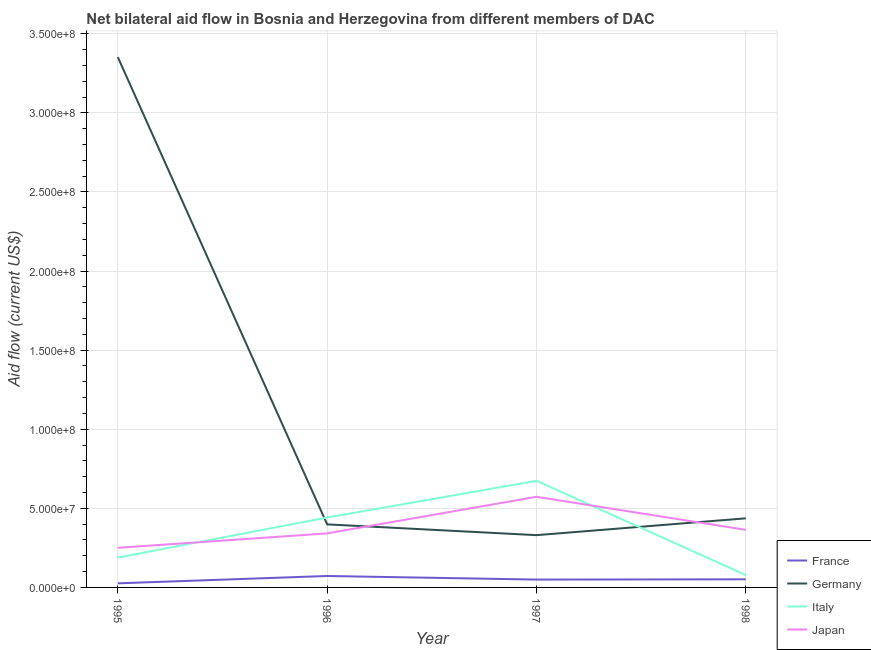What is the amount of aid given by germany in 1998?
Keep it short and to the point. 4.37e+07. Across all years, what is the maximum amount of aid given by germany?
Your answer should be very brief. 3.35e+08. Across all years, what is the minimum amount of aid given by italy?
Offer a terse response. 7.77e+06. In which year was the amount of aid given by italy maximum?
Offer a very short reply. 1997. In which year was the amount of aid given by germany minimum?
Ensure brevity in your answer.  1997. What is the total amount of aid given by france in the graph?
Make the answer very short. 1.99e+07. What is the difference between the amount of aid given by japan in 1996 and that in 1998?
Offer a very short reply. -2.23e+06. What is the difference between the amount of aid given by italy in 1998 and the amount of aid given by france in 1996?
Make the answer very short. 5.40e+05. What is the average amount of aid given by germany per year?
Provide a succinct answer. 1.13e+08. In the year 1995, what is the difference between the amount of aid given by france and amount of aid given by italy?
Give a very brief answer. -1.63e+07. In how many years, is the amount of aid given by italy greater than 180000000 US$?
Offer a very short reply. 0. What is the ratio of the amount of aid given by france in 1996 to that in 1997?
Offer a very short reply. 1.46. Is the amount of aid given by germany in 1996 less than that in 1997?
Your response must be concise. No. What is the difference between the highest and the second highest amount of aid given by japan?
Provide a succinct answer. 2.09e+07. What is the difference between the highest and the lowest amount of aid given by italy?
Your answer should be very brief. 5.96e+07. In how many years, is the amount of aid given by germany greater than the average amount of aid given by germany taken over all years?
Provide a short and direct response. 1. Is it the case that in every year, the sum of the amount of aid given by japan and amount of aid given by france is greater than the sum of amount of aid given by italy and amount of aid given by germany?
Give a very brief answer. No. Does the amount of aid given by italy monotonically increase over the years?
Offer a terse response. No. Is the amount of aid given by france strictly greater than the amount of aid given by germany over the years?
Offer a terse response. No. Is the amount of aid given by japan strictly less than the amount of aid given by france over the years?
Your answer should be very brief. No. Are the values on the major ticks of Y-axis written in scientific E-notation?
Offer a terse response. Yes. What is the title of the graph?
Provide a short and direct response. Net bilateral aid flow in Bosnia and Herzegovina from different members of DAC. Does "Secondary vocational" appear as one of the legend labels in the graph?
Provide a short and direct response. No. What is the Aid flow (current US$) of France in 1995?
Your answer should be compact. 2.59e+06. What is the Aid flow (current US$) in Germany in 1995?
Offer a terse response. 3.35e+08. What is the Aid flow (current US$) of Italy in 1995?
Your response must be concise. 1.89e+07. What is the Aid flow (current US$) of Japan in 1995?
Offer a very short reply. 2.50e+07. What is the Aid flow (current US$) of France in 1996?
Make the answer very short. 7.23e+06. What is the Aid flow (current US$) in Germany in 1996?
Your answer should be very brief. 3.99e+07. What is the Aid flow (current US$) in Italy in 1996?
Provide a short and direct response. 4.42e+07. What is the Aid flow (current US$) of Japan in 1996?
Offer a terse response. 3.42e+07. What is the Aid flow (current US$) in France in 1997?
Provide a succinct answer. 4.96e+06. What is the Aid flow (current US$) of Germany in 1997?
Keep it short and to the point. 3.30e+07. What is the Aid flow (current US$) of Italy in 1997?
Ensure brevity in your answer.  6.74e+07. What is the Aid flow (current US$) in Japan in 1997?
Keep it short and to the point. 5.73e+07. What is the Aid flow (current US$) in France in 1998?
Offer a very short reply. 5.13e+06. What is the Aid flow (current US$) of Germany in 1998?
Offer a very short reply. 4.37e+07. What is the Aid flow (current US$) of Italy in 1998?
Offer a terse response. 7.77e+06. What is the Aid flow (current US$) in Japan in 1998?
Ensure brevity in your answer.  3.64e+07. Across all years, what is the maximum Aid flow (current US$) in France?
Ensure brevity in your answer.  7.23e+06. Across all years, what is the maximum Aid flow (current US$) of Germany?
Ensure brevity in your answer.  3.35e+08. Across all years, what is the maximum Aid flow (current US$) of Italy?
Offer a terse response. 6.74e+07. Across all years, what is the maximum Aid flow (current US$) in Japan?
Keep it short and to the point. 5.73e+07. Across all years, what is the minimum Aid flow (current US$) of France?
Ensure brevity in your answer.  2.59e+06. Across all years, what is the minimum Aid flow (current US$) in Germany?
Give a very brief answer. 3.30e+07. Across all years, what is the minimum Aid flow (current US$) in Italy?
Ensure brevity in your answer.  7.77e+06. Across all years, what is the minimum Aid flow (current US$) of Japan?
Your answer should be compact. 2.50e+07. What is the total Aid flow (current US$) of France in the graph?
Your response must be concise. 1.99e+07. What is the total Aid flow (current US$) of Germany in the graph?
Provide a short and direct response. 4.52e+08. What is the total Aid flow (current US$) in Italy in the graph?
Make the answer very short. 1.38e+08. What is the total Aid flow (current US$) of Japan in the graph?
Your answer should be very brief. 1.53e+08. What is the difference between the Aid flow (current US$) in France in 1995 and that in 1996?
Your answer should be very brief. -4.64e+06. What is the difference between the Aid flow (current US$) of Germany in 1995 and that in 1996?
Ensure brevity in your answer.  2.95e+08. What is the difference between the Aid flow (current US$) of Italy in 1995 and that in 1996?
Provide a succinct answer. -2.53e+07. What is the difference between the Aid flow (current US$) of Japan in 1995 and that in 1996?
Your answer should be very brief. -9.13e+06. What is the difference between the Aid flow (current US$) in France in 1995 and that in 1997?
Provide a succinct answer. -2.37e+06. What is the difference between the Aid flow (current US$) in Germany in 1995 and that in 1997?
Provide a succinct answer. 3.02e+08. What is the difference between the Aid flow (current US$) of Italy in 1995 and that in 1997?
Give a very brief answer. -4.85e+07. What is the difference between the Aid flow (current US$) of Japan in 1995 and that in 1997?
Offer a very short reply. -3.22e+07. What is the difference between the Aid flow (current US$) of France in 1995 and that in 1998?
Provide a short and direct response. -2.54e+06. What is the difference between the Aid flow (current US$) of Germany in 1995 and that in 1998?
Keep it short and to the point. 2.92e+08. What is the difference between the Aid flow (current US$) of Italy in 1995 and that in 1998?
Your answer should be very brief. 1.11e+07. What is the difference between the Aid flow (current US$) in Japan in 1995 and that in 1998?
Ensure brevity in your answer.  -1.14e+07. What is the difference between the Aid flow (current US$) of France in 1996 and that in 1997?
Offer a very short reply. 2.27e+06. What is the difference between the Aid flow (current US$) of Germany in 1996 and that in 1997?
Provide a short and direct response. 6.81e+06. What is the difference between the Aid flow (current US$) in Italy in 1996 and that in 1997?
Your answer should be compact. -2.32e+07. What is the difference between the Aid flow (current US$) in Japan in 1996 and that in 1997?
Your response must be concise. -2.31e+07. What is the difference between the Aid flow (current US$) of France in 1996 and that in 1998?
Ensure brevity in your answer.  2.10e+06. What is the difference between the Aid flow (current US$) in Germany in 1996 and that in 1998?
Provide a short and direct response. -3.82e+06. What is the difference between the Aid flow (current US$) in Italy in 1996 and that in 1998?
Offer a terse response. 3.64e+07. What is the difference between the Aid flow (current US$) in Japan in 1996 and that in 1998?
Offer a very short reply. -2.23e+06. What is the difference between the Aid flow (current US$) of France in 1997 and that in 1998?
Make the answer very short. -1.70e+05. What is the difference between the Aid flow (current US$) of Germany in 1997 and that in 1998?
Keep it short and to the point. -1.06e+07. What is the difference between the Aid flow (current US$) in Italy in 1997 and that in 1998?
Give a very brief answer. 5.96e+07. What is the difference between the Aid flow (current US$) of Japan in 1997 and that in 1998?
Provide a short and direct response. 2.09e+07. What is the difference between the Aid flow (current US$) of France in 1995 and the Aid flow (current US$) of Germany in 1996?
Your response must be concise. -3.73e+07. What is the difference between the Aid flow (current US$) of France in 1995 and the Aid flow (current US$) of Italy in 1996?
Provide a succinct answer. -4.16e+07. What is the difference between the Aid flow (current US$) in France in 1995 and the Aid flow (current US$) in Japan in 1996?
Provide a succinct answer. -3.16e+07. What is the difference between the Aid flow (current US$) in Germany in 1995 and the Aid flow (current US$) in Italy in 1996?
Keep it short and to the point. 2.91e+08. What is the difference between the Aid flow (current US$) in Germany in 1995 and the Aid flow (current US$) in Japan in 1996?
Make the answer very short. 3.01e+08. What is the difference between the Aid flow (current US$) of Italy in 1995 and the Aid flow (current US$) of Japan in 1996?
Make the answer very short. -1.53e+07. What is the difference between the Aid flow (current US$) in France in 1995 and the Aid flow (current US$) in Germany in 1997?
Provide a short and direct response. -3.05e+07. What is the difference between the Aid flow (current US$) of France in 1995 and the Aid flow (current US$) of Italy in 1997?
Ensure brevity in your answer.  -6.48e+07. What is the difference between the Aid flow (current US$) in France in 1995 and the Aid flow (current US$) in Japan in 1997?
Provide a succinct answer. -5.47e+07. What is the difference between the Aid flow (current US$) of Germany in 1995 and the Aid flow (current US$) of Italy in 1997?
Offer a terse response. 2.68e+08. What is the difference between the Aid flow (current US$) in Germany in 1995 and the Aid flow (current US$) in Japan in 1997?
Provide a short and direct response. 2.78e+08. What is the difference between the Aid flow (current US$) in Italy in 1995 and the Aid flow (current US$) in Japan in 1997?
Offer a very short reply. -3.84e+07. What is the difference between the Aid flow (current US$) in France in 1995 and the Aid flow (current US$) in Germany in 1998?
Keep it short and to the point. -4.11e+07. What is the difference between the Aid flow (current US$) in France in 1995 and the Aid flow (current US$) in Italy in 1998?
Ensure brevity in your answer.  -5.18e+06. What is the difference between the Aid flow (current US$) in France in 1995 and the Aid flow (current US$) in Japan in 1998?
Make the answer very short. -3.38e+07. What is the difference between the Aid flow (current US$) in Germany in 1995 and the Aid flow (current US$) in Italy in 1998?
Provide a short and direct response. 3.27e+08. What is the difference between the Aid flow (current US$) in Germany in 1995 and the Aid flow (current US$) in Japan in 1998?
Keep it short and to the point. 2.99e+08. What is the difference between the Aid flow (current US$) of Italy in 1995 and the Aid flow (current US$) of Japan in 1998?
Your answer should be very brief. -1.75e+07. What is the difference between the Aid flow (current US$) in France in 1996 and the Aid flow (current US$) in Germany in 1997?
Offer a very short reply. -2.58e+07. What is the difference between the Aid flow (current US$) of France in 1996 and the Aid flow (current US$) of Italy in 1997?
Provide a succinct answer. -6.02e+07. What is the difference between the Aid flow (current US$) in France in 1996 and the Aid flow (current US$) in Japan in 1997?
Provide a short and direct response. -5.01e+07. What is the difference between the Aid flow (current US$) of Germany in 1996 and the Aid flow (current US$) of Italy in 1997?
Ensure brevity in your answer.  -2.75e+07. What is the difference between the Aid flow (current US$) of Germany in 1996 and the Aid flow (current US$) of Japan in 1997?
Keep it short and to the point. -1.74e+07. What is the difference between the Aid flow (current US$) of Italy in 1996 and the Aid flow (current US$) of Japan in 1997?
Your answer should be compact. -1.31e+07. What is the difference between the Aid flow (current US$) of France in 1996 and the Aid flow (current US$) of Germany in 1998?
Offer a terse response. -3.64e+07. What is the difference between the Aid flow (current US$) of France in 1996 and the Aid flow (current US$) of Italy in 1998?
Offer a terse response. -5.40e+05. What is the difference between the Aid flow (current US$) of France in 1996 and the Aid flow (current US$) of Japan in 1998?
Make the answer very short. -2.92e+07. What is the difference between the Aid flow (current US$) in Germany in 1996 and the Aid flow (current US$) in Italy in 1998?
Make the answer very short. 3.21e+07. What is the difference between the Aid flow (current US$) of Germany in 1996 and the Aid flow (current US$) of Japan in 1998?
Your response must be concise. 3.46e+06. What is the difference between the Aid flow (current US$) in Italy in 1996 and the Aid flow (current US$) in Japan in 1998?
Give a very brief answer. 7.82e+06. What is the difference between the Aid flow (current US$) in France in 1997 and the Aid flow (current US$) in Germany in 1998?
Keep it short and to the point. -3.87e+07. What is the difference between the Aid flow (current US$) of France in 1997 and the Aid flow (current US$) of Italy in 1998?
Offer a terse response. -2.81e+06. What is the difference between the Aid flow (current US$) of France in 1997 and the Aid flow (current US$) of Japan in 1998?
Your response must be concise. -3.14e+07. What is the difference between the Aid flow (current US$) of Germany in 1997 and the Aid flow (current US$) of Italy in 1998?
Provide a short and direct response. 2.53e+07. What is the difference between the Aid flow (current US$) in Germany in 1997 and the Aid flow (current US$) in Japan in 1998?
Keep it short and to the point. -3.35e+06. What is the difference between the Aid flow (current US$) in Italy in 1997 and the Aid flow (current US$) in Japan in 1998?
Give a very brief answer. 3.10e+07. What is the average Aid flow (current US$) of France per year?
Give a very brief answer. 4.98e+06. What is the average Aid flow (current US$) in Germany per year?
Offer a very short reply. 1.13e+08. What is the average Aid flow (current US$) in Italy per year?
Keep it short and to the point. 3.46e+07. What is the average Aid flow (current US$) in Japan per year?
Give a very brief answer. 3.82e+07. In the year 1995, what is the difference between the Aid flow (current US$) in France and Aid flow (current US$) in Germany?
Ensure brevity in your answer.  -3.33e+08. In the year 1995, what is the difference between the Aid flow (current US$) of France and Aid flow (current US$) of Italy?
Your answer should be very brief. -1.63e+07. In the year 1995, what is the difference between the Aid flow (current US$) in France and Aid flow (current US$) in Japan?
Offer a terse response. -2.24e+07. In the year 1995, what is the difference between the Aid flow (current US$) in Germany and Aid flow (current US$) in Italy?
Ensure brevity in your answer.  3.16e+08. In the year 1995, what is the difference between the Aid flow (current US$) of Germany and Aid flow (current US$) of Japan?
Offer a terse response. 3.10e+08. In the year 1995, what is the difference between the Aid flow (current US$) in Italy and Aid flow (current US$) in Japan?
Your answer should be very brief. -6.16e+06. In the year 1996, what is the difference between the Aid flow (current US$) in France and Aid flow (current US$) in Germany?
Your answer should be very brief. -3.26e+07. In the year 1996, what is the difference between the Aid flow (current US$) of France and Aid flow (current US$) of Italy?
Keep it short and to the point. -3.70e+07. In the year 1996, what is the difference between the Aid flow (current US$) in France and Aid flow (current US$) in Japan?
Your answer should be compact. -2.69e+07. In the year 1996, what is the difference between the Aid flow (current US$) in Germany and Aid flow (current US$) in Italy?
Your answer should be compact. -4.36e+06. In the year 1996, what is the difference between the Aid flow (current US$) of Germany and Aid flow (current US$) of Japan?
Offer a very short reply. 5.69e+06. In the year 1996, what is the difference between the Aid flow (current US$) in Italy and Aid flow (current US$) in Japan?
Your response must be concise. 1.00e+07. In the year 1997, what is the difference between the Aid flow (current US$) in France and Aid flow (current US$) in Germany?
Keep it short and to the point. -2.81e+07. In the year 1997, what is the difference between the Aid flow (current US$) in France and Aid flow (current US$) in Italy?
Your response must be concise. -6.24e+07. In the year 1997, what is the difference between the Aid flow (current US$) in France and Aid flow (current US$) in Japan?
Offer a terse response. -5.23e+07. In the year 1997, what is the difference between the Aid flow (current US$) of Germany and Aid flow (current US$) of Italy?
Offer a terse response. -3.44e+07. In the year 1997, what is the difference between the Aid flow (current US$) of Germany and Aid flow (current US$) of Japan?
Give a very brief answer. -2.42e+07. In the year 1997, what is the difference between the Aid flow (current US$) in Italy and Aid flow (current US$) in Japan?
Ensure brevity in your answer.  1.01e+07. In the year 1998, what is the difference between the Aid flow (current US$) of France and Aid flow (current US$) of Germany?
Your answer should be compact. -3.86e+07. In the year 1998, what is the difference between the Aid flow (current US$) in France and Aid flow (current US$) in Italy?
Your answer should be very brief. -2.64e+06. In the year 1998, what is the difference between the Aid flow (current US$) in France and Aid flow (current US$) in Japan?
Your answer should be compact. -3.13e+07. In the year 1998, what is the difference between the Aid flow (current US$) in Germany and Aid flow (current US$) in Italy?
Your answer should be very brief. 3.59e+07. In the year 1998, what is the difference between the Aid flow (current US$) in Germany and Aid flow (current US$) in Japan?
Your answer should be compact. 7.28e+06. In the year 1998, what is the difference between the Aid flow (current US$) in Italy and Aid flow (current US$) in Japan?
Your response must be concise. -2.86e+07. What is the ratio of the Aid flow (current US$) in France in 1995 to that in 1996?
Your response must be concise. 0.36. What is the ratio of the Aid flow (current US$) in Germany in 1995 to that in 1996?
Your answer should be compact. 8.41. What is the ratio of the Aid flow (current US$) of Italy in 1995 to that in 1996?
Your answer should be very brief. 0.43. What is the ratio of the Aid flow (current US$) in Japan in 1995 to that in 1996?
Provide a succinct answer. 0.73. What is the ratio of the Aid flow (current US$) in France in 1995 to that in 1997?
Your answer should be compact. 0.52. What is the ratio of the Aid flow (current US$) of Germany in 1995 to that in 1997?
Make the answer very short. 10.14. What is the ratio of the Aid flow (current US$) in Italy in 1995 to that in 1997?
Your response must be concise. 0.28. What is the ratio of the Aid flow (current US$) of Japan in 1995 to that in 1997?
Your response must be concise. 0.44. What is the ratio of the Aid flow (current US$) in France in 1995 to that in 1998?
Ensure brevity in your answer.  0.5. What is the ratio of the Aid flow (current US$) in Germany in 1995 to that in 1998?
Your response must be concise. 7.67. What is the ratio of the Aid flow (current US$) in Italy in 1995 to that in 1998?
Ensure brevity in your answer.  2.43. What is the ratio of the Aid flow (current US$) in Japan in 1995 to that in 1998?
Your answer should be very brief. 0.69. What is the ratio of the Aid flow (current US$) of France in 1996 to that in 1997?
Ensure brevity in your answer.  1.46. What is the ratio of the Aid flow (current US$) of Germany in 1996 to that in 1997?
Offer a terse response. 1.21. What is the ratio of the Aid flow (current US$) in Italy in 1996 to that in 1997?
Ensure brevity in your answer.  0.66. What is the ratio of the Aid flow (current US$) in Japan in 1996 to that in 1997?
Give a very brief answer. 0.6. What is the ratio of the Aid flow (current US$) in France in 1996 to that in 1998?
Your answer should be very brief. 1.41. What is the ratio of the Aid flow (current US$) of Germany in 1996 to that in 1998?
Make the answer very short. 0.91. What is the ratio of the Aid flow (current US$) in Italy in 1996 to that in 1998?
Your answer should be compact. 5.69. What is the ratio of the Aid flow (current US$) in Japan in 1996 to that in 1998?
Provide a succinct answer. 0.94. What is the ratio of the Aid flow (current US$) in France in 1997 to that in 1998?
Ensure brevity in your answer.  0.97. What is the ratio of the Aid flow (current US$) of Germany in 1997 to that in 1998?
Make the answer very short. 0.76. What is the ratio of the Aid flow (current US$) in Italy in 1997 to that in 1998?
Provide a short and direct response. 8.67. What is the ratio of the Aid flow (current US$) of Japan in 1997 to that in 1998?
Provide a succinct answer. 1.57. What is the difference between the highest and the second highest Aid flow (current US$) of France?
Offer a very short reply. 2.10e+06. What is the difference between the highest and the second highest Aid flow (current US$) of Germany?
Offer a terse response. 2.92e+08. What is the difference between the highest and the second highest Aid flow (current US$) in Italy?
Your response must be concise. 2.32e+07. What is the difference between the highest and the second highest Aid flow (current US$) in Japan?
Provide a short and direct response. 2.09e+07. What is the difference between the highest and the lowest Aid flow (current US$) of France?
Offer a terse response. 4.64e+06. What is the difference between the highest and the lowest Aid flow (current US$) of Germany?
Your answer should be very brief. 3.02e+08. What is the difference between the highest and the lowest Aid flow (current US$) of Italy?
Provide a short and direct response. 5.96e+07. What is the difference between the highest and the lowest Aid flow (current US$) of Japan?
Your answer should be compact. 3.22e+07. 